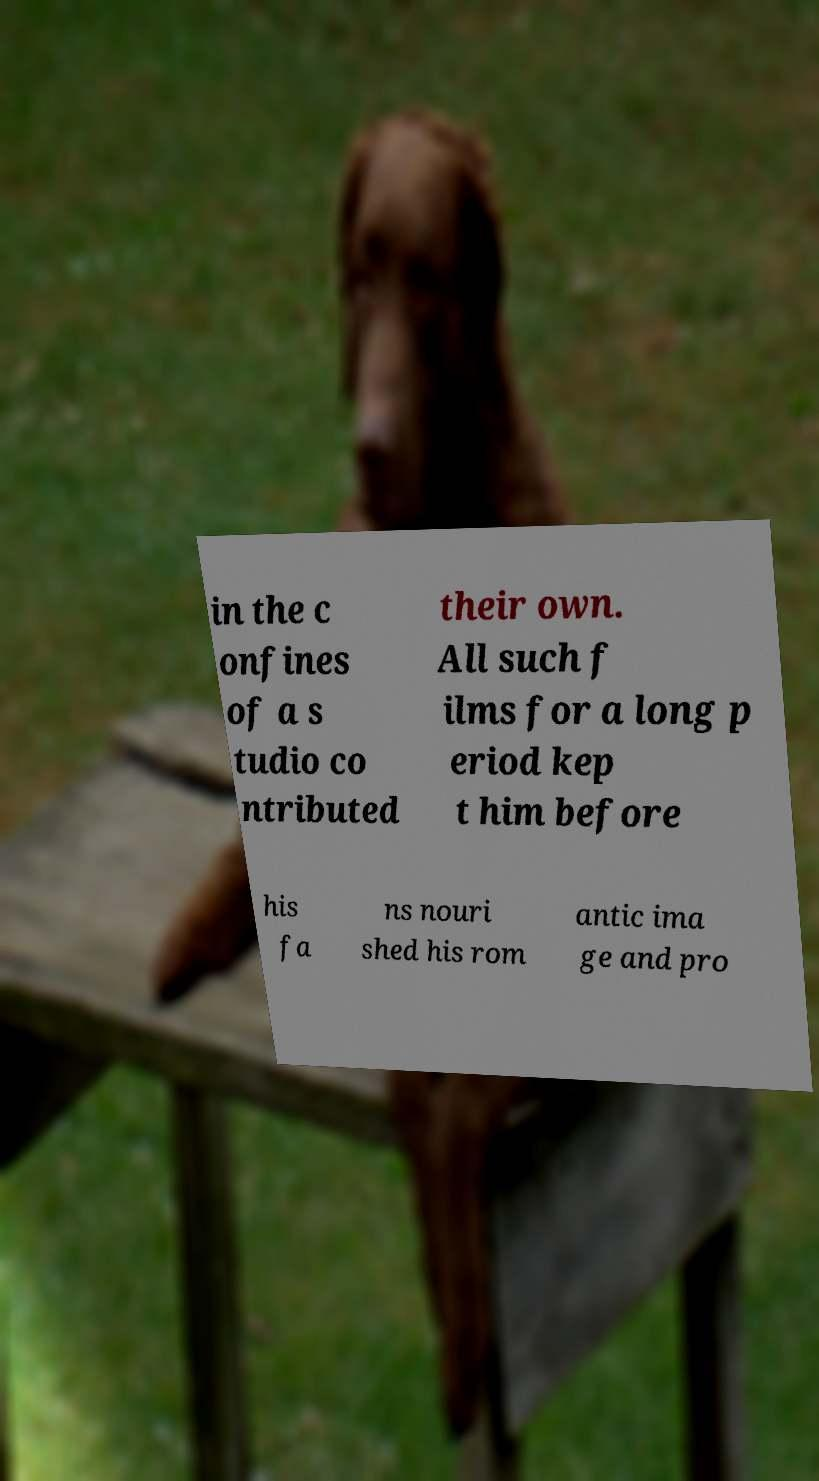Could you assist in decoding the text presented in this image and type it out clearly? in the c onfines of a s tudio co ntributed their own. All such f ilms for a long p eriod kep t him before his fa ns nouri shed his rom antic ima ge and pro 